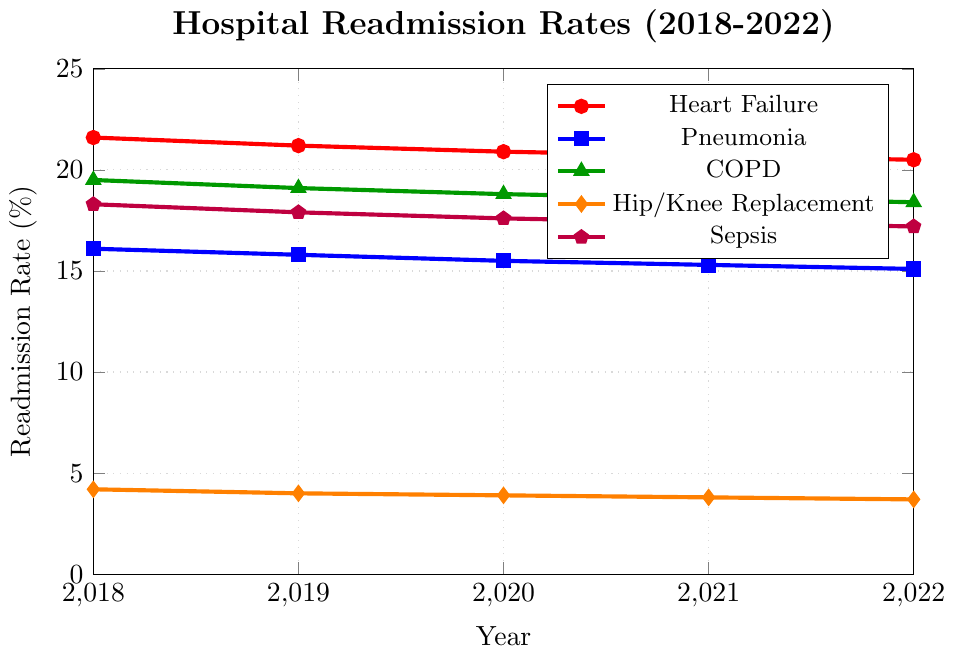What's the trend in the readmission rate for Heart Failure over the past 5 years? To determine the trend, observe the readmission rates for Heart Failure from 2018 to 2022. The values decrease from 21.6% in 2018 to 20.5% in 2022. This indicates a downward trend.
Answer: Downward trend How do the readmission rates for COPD and Pneumonia in 2022 compare? In 2022, the readmission rate for COPD is 18.4%, while for Pneumonia it is 15.1%. COPD has a higher readmission rate compared to Pneumonia.
Answer: COPD is higher What is the average readmission rate for Hip/Knee Replacement over the years? To calculate the average, add the readmission rates for Hip/Knee Replacement from 2018 to 2022 (4.2 + 4.0 + 3.9 + 3.8 + 3.7) and divide by 5. The sum is 19.6, so the average is 19.6/5 = 3.92%.
Answer: 3.92% Which condition has the lowest readmission rate in 2021, and what is that rate? Look at the rates for 2021: Heart Failure (20.7), Pneumonia (15.3), COPD (18.6), Hip/Knee Replacement (3.8), Sepsis (17.4). Hip/Knee Replacement has the lowest rate of 3.8%.
Answer: Hip/Knee Replacement, 3.8% By how much did the readmission rate for Sepsis decrease from 2018 to 2022? Subtract the 2022 rate from the 2018 rate for Sepsis (18.3 - 17.2). The decrease is 1.1%.
Answer: 1.1% What color represents Pneumonia in the chart? The legend indicates which color corresponds to which condition. For Pneumonia, the color is blue.
Answer: Blue Which condition saw the smallest absolute decrease in readmission rate from 2018 to 2022? Calculate the absolute decrease for each condition from 2018 to 2022: Heart Failure (1.1), Pneumonia (1.0), COPD (1.1), Hip/Knee Replacement (0.5), Sepsis (1.1). Hip/Knee Replacement has the smallest decrease of 0.5%.
Answer: Hip/Knee Replacement What's the total readmission rate for Heart Failure and Pneumonia combined in 2020? Sum the readmission rates for Heart Failure (20.9) and Pneumonia (15.5) in 2020. The total is 20.9 + 15.5 = 36.4%.
Answer: 36.4% How many conditions had a readmission rate above 15% in 2022? Identify the conditions with rates above 15% in 2022: Heart Failure (20.5), Pneumonia (15.1), COPD (18.4), Sepsis (17.2). Four conditions meet the criteria.
Answer: Four For which year is the difference between the readmission rates of COPD and Sepsis the smallest? Calculate the differences for each year: 2018 (19.5 - 18.3 = 1.2), 2019 (19.1 - 17.9 = 1.2), 2020 (18.8 - 17.6 = 1.2), 2021 (18.6 - 17.4 = 1.2), 2022 (18.4 - 17.2 = 1.2). The difference is consistently 1.2 each year, so the smallest difference is equal for all years.
Answer: All years 